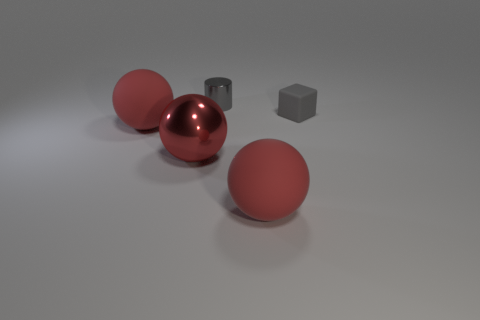How many red spheres must be subtracted to get 1 red spheres? 2 Add 3 gray metal things. How many objects exist? 8 Subtract all cubes. How many objects are left? 4 Add 5 tiny yellow metallic objects. How many tiny yellow metallic objects exist? 5 Subtract 0 green balls. How many objects are left? 5 Subtract all rubber balls. Subtract all big red metallic things. How many objects are left? 2 Add 2 gray cylinders. How many gray cylinders are left? 3 